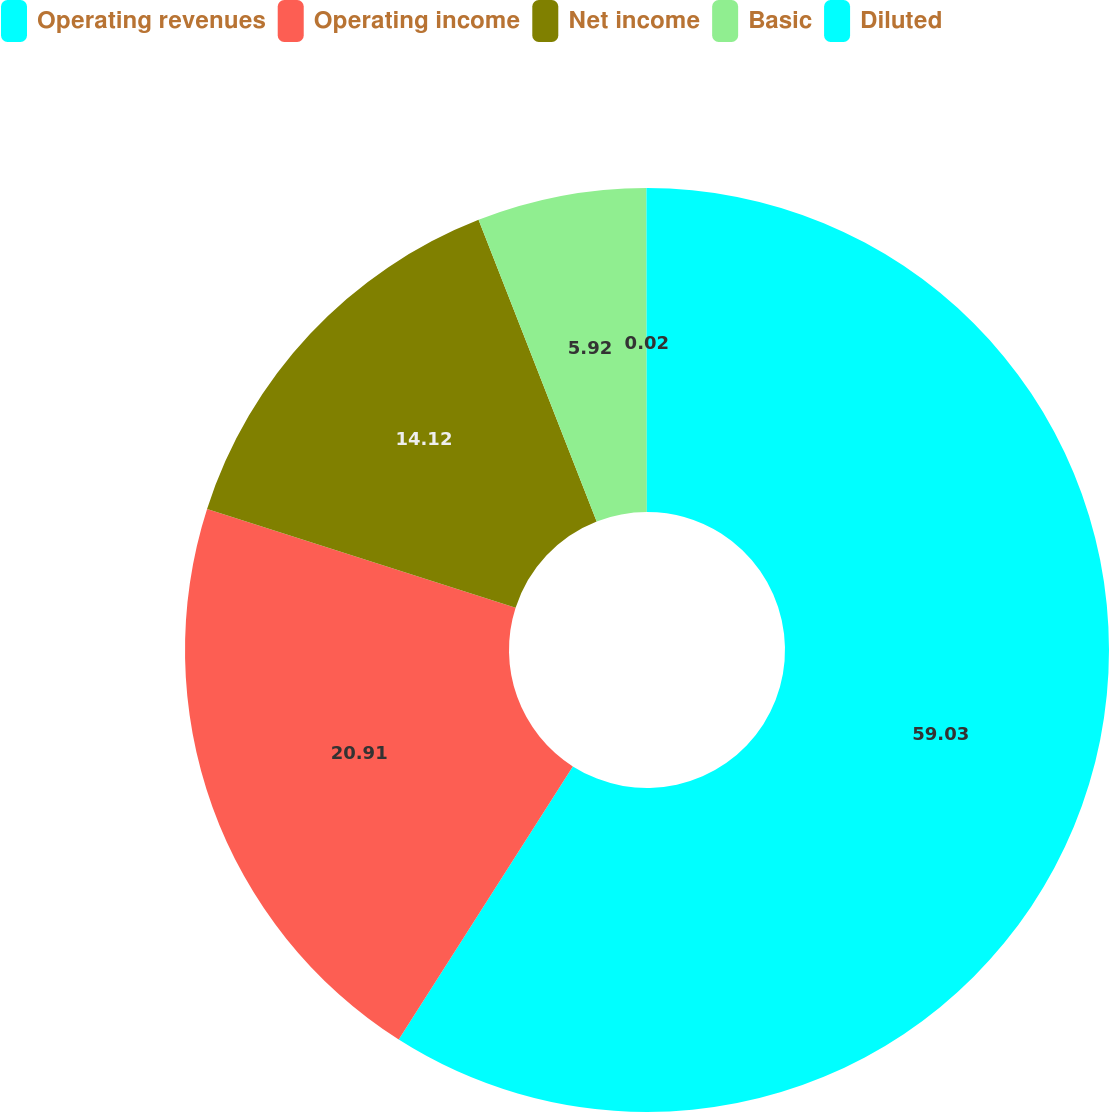Convert chart. <chart><loc_0><loc_0><loc_500><loc_500><pie_chart><fcel>Operating revenues<fcel>Operating income<fcel>Net income<fcel>Basic<fcel>Diluted<nl><fcel>59.03%<fcel>20.91%<fcel>14.12%<fcel>5.92%<fcel>0.02%<nl></chart> 